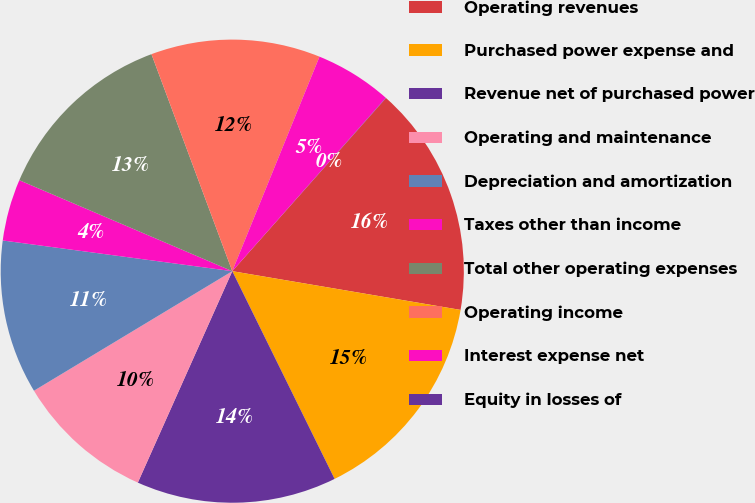Convert chart. <chart><loc_0><loc_0><loc_500><loc_500><pie_chart><fcel>Operating revenues<fcel>Purchased power expense and<fcel>Revenue net of purchased power<fcel>Operating and maintenance<fcel>Depreciation and amortization<fcel>Taxes other than income<fcel>Total other operating expenses<fcel>Operating income<fcel>Interest expense net<fcel>Equity in losses of<nl><fcel>16.12%<fcel>15.04%<fcel>13.97%<fcel>9.68%<fcel>10.75%<fcel>4.31%<fcel>12.9%<fcel>11.82%<fcel>5.39%<fcel>0.02%<nl></chart> 